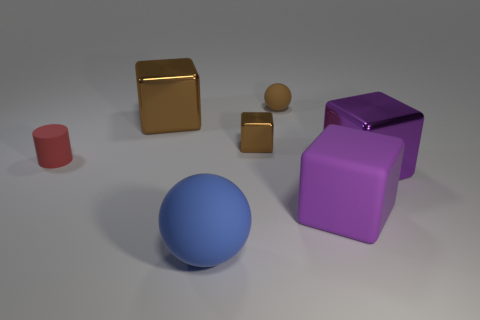There is a sphere that is behind the small matte thing that is in front of the rubber ball behind the purple metal block; what is its material?
Offer a very short reply. Rubber. What number of other objects are the same size as the brown sphere?
Make the answer very short. 2. Do the small cylinder and the rubber cube have the same color?
Your answer should be very brief. No. What number of cylinders are behind the shiny object that is on the right side of the brown metallic block to the right of the blue rubber object?
Offer a terse response. 1. What is the material of the sphere that is left of the ball that is behind the tiny red rubber cylinder?
Provide a short and direct response. Rubber. Is there a big purple rubber thing that has the same shape as the red matte thing?
Make the answer very short. No. There is a matte sphere that is the same size as the matte cylinder; what is its color?
Offer a terse response. Brown. How many objects are either big metallic objects right of the small brown block or large metallic cubes that are to the right of the brown ball?
Make the answer very short. 1. What number of objects are either small brown cubes or purple objects?
Keep it short and to the point. 3. There is a matte thing that is to the left of the small brown cube and in front of the cylinder; how big is it?
Give a very brief answer. Large. 